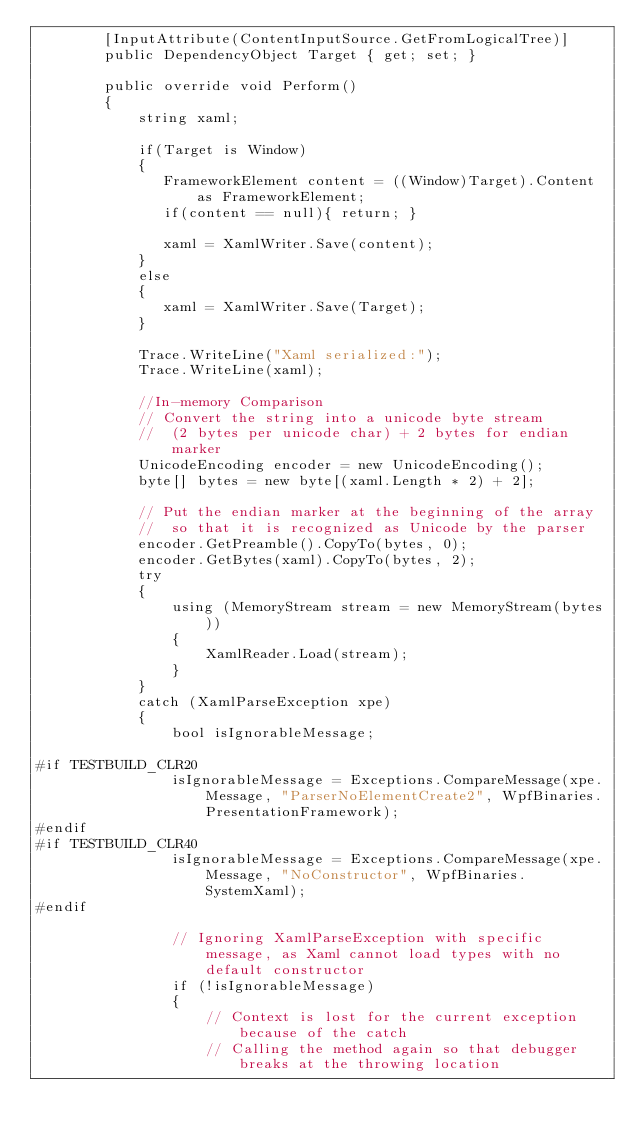<code> <loc_0><loc_0><loc_500><loc_500><_C#_>        [InputAttribute(ContentInputSource.GetFromLogicalTree)]
        public DependencyObject Target { get; set; }

        public override void Perform()
        {
            string xaml;

            if(Target is Window)
            {
               FrameworkElement content = ((Window)Target).Content as FrameworkElement;
               if(content == null){ return; }

               xaml = XamlWriter.Save(content);
            }
            else
            {
               xaml = XamlWriter.Save(Target);
            }

            Trace.WriteLine("Xaml serialized:");
            Trace.WriteLine(xaml);

            //In-memory Comparison
            // Convert the string into a unicode byte stream
            //  (2 bytes per unicode char) + 2 bytes for endian marker
            UnicodeEncoding encoder = new UnicodeEncoding();
            byte[] bytes = new byte[(xaml.Length * 2) + 2];

            // Put the endian marker at the beginning of the array
            //  so that it is recognized as Unicode by the parser
            encoder.GetPreamble().CopyTo(bytes, 0);
            encoder.GetBytes(xaml).CopyTo(bytes, 2);
            try
            {
                using (MemoryStream stream = new MemoryStream(bytes))
                {
                    XamlReader.Load(stream);
                }
            }
            catch (XamlParseException xpe)
            {
                bool isIgnorableMessage;

#if TESTBUILD_CLR20
                isIgnorableMessage = Exceptions.CompareMessage(xpe.Message, "ParserNoElementCreate2", WpfBinaries.PresentationFramework);
#endif
#if TESTBUILD_CLR40
                isIgnorableMessage = Exceptions.CompareMessage(xpe.Message, "NoConstructor", WpfBinaries.SystemXaml);
#endif

                // Ignoring XamlParseException with specific message, as Xaml cannot load types with no default constructor
                if (!isIgnorableMessage)
                {
                    // Context is lost for the current exception because of the catch
                    // Calling the method again so that debugger breaks at the throwing location</code> 